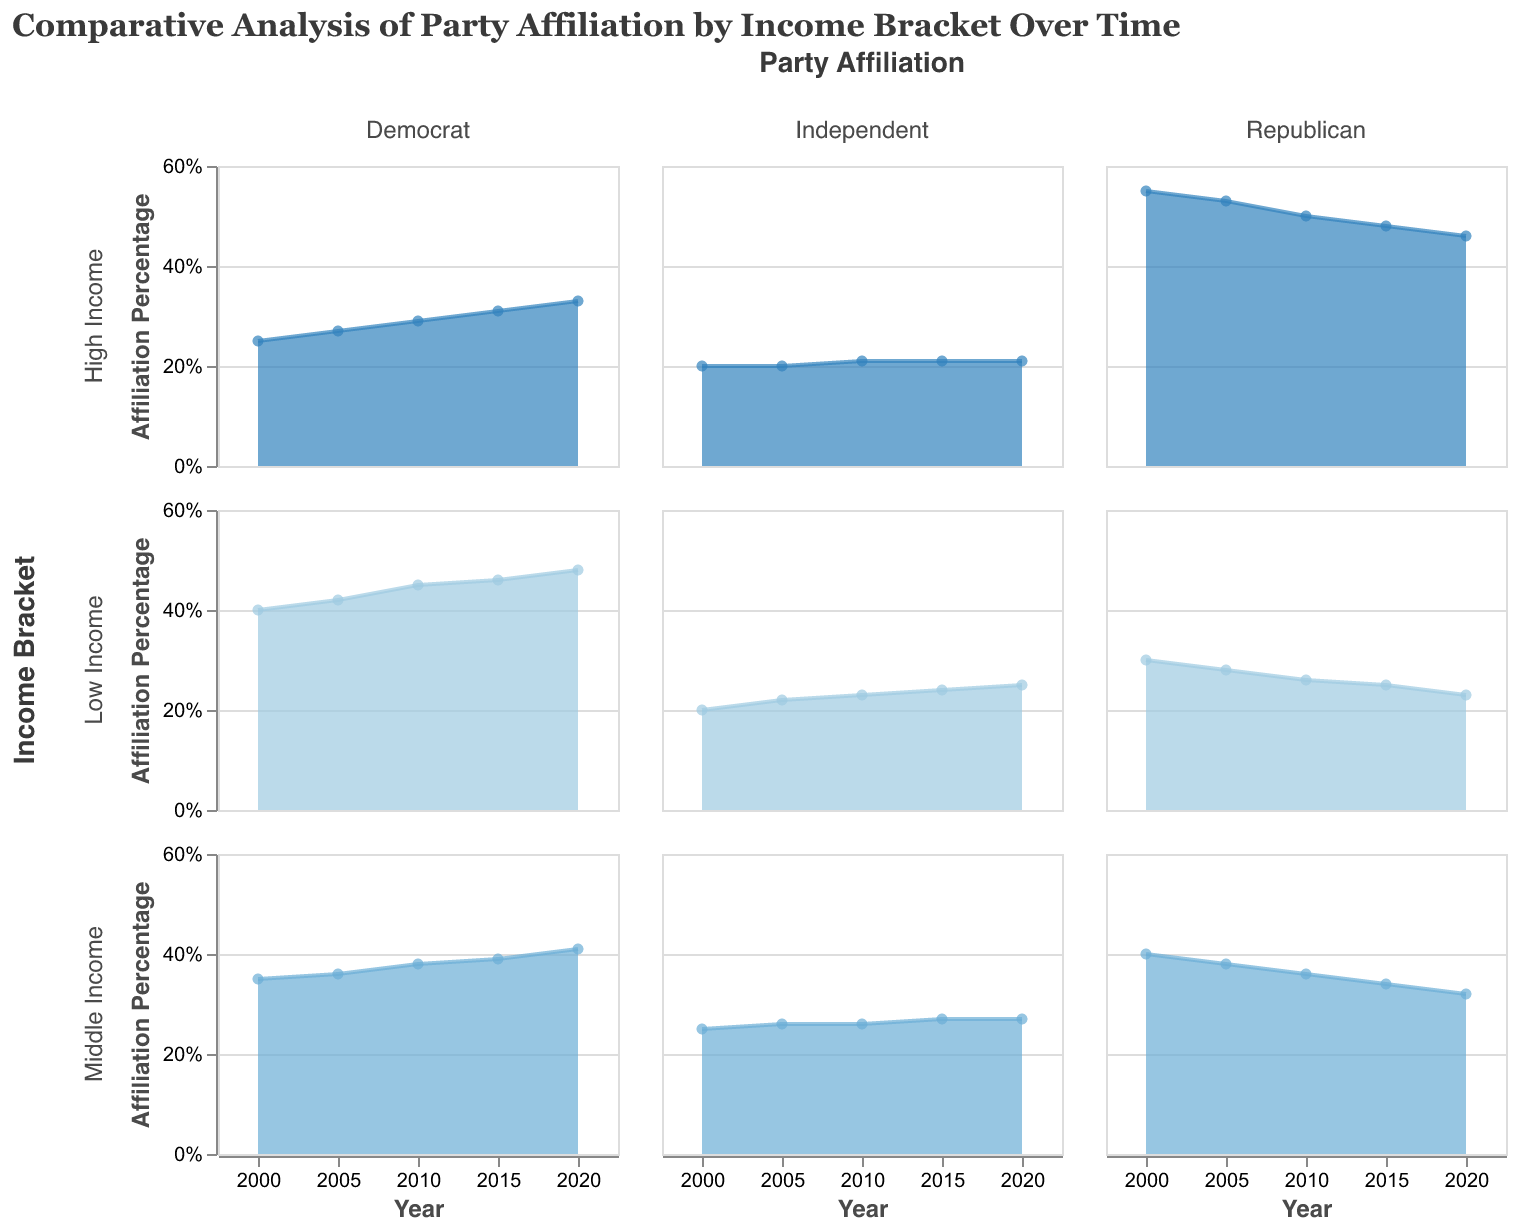What is the title of the figure? The title of the figure is located at the top and reads "Comparative Analysis of Party Affiliation by Income Bracket Over Time."
Answer: Comparative Analysis of Party Affiliation by Income Bracket Over Time Which income bracket has the highest percentage of Democrat affiliation in 2020? Looking under the Democrat column in 2020, the values for Low Income, Middle Income, and High Income are 0.48, 0.41, and 0.33, respectively. The highest percentage is for Low Income at 0.48.
Answer: Low Income What is the trend of Republican affiliation for High Income from 2000 to 2020? In the High Income bracket under the Republican column, the percentages from 2000 to 2020 show a declining trend: 0.55, 0.53, 0.5, 0.48, and 0.46, respectively.
Answer: Declining Compare the change in affiliation percentage for Middle Income Democrats and Republicans from 2000 to 2020. For Middle Income Democrats, the percentage goes from 0.35 in 2000 to 0.41 in 2020, an increase of 0.06. For Middle Income Republicans, the percentage goes from 0.4 in 2000 to 0.32 in 2020, a decrease of 0.08.
Answer: Democrats increased by 0.06, Republicans decreased by 0.08 Between 2000 and 2020, which party affiliation for Low Income had the most significant change? Looking under Low Income from 2000 to 2020 for all three parties: Democrat increased from 0.4 to 0.48 (0.08), Republican decreased from 0.3 to 0.23 (0.07), Independent increased from 0.2 to 0.25 (0.05). The most significant change is Democrats with an increase of 0.08.
Answer: Democrat What was the percentage of Independent affiliation for Middle Income in 2010? Under the Independent column for Middle Income in 2010, the percentage is given as 0.26.
Answer: 0.26 Which party affiliation category shows the least change over time for High Income? Looking at the High Income row, the changes from 2000 to 2020 are: Democrat (0.25 to 0.33, a change of 0.08), Republican (0.55 to 0.46, a change of 0.09), and Independent (0.2 to 0.21, a change of 0.01). The Independent category exhibits the least change.
Answer: Independent What is the overall trend for Independent affiliation across all income brackets from 2000 to 2020? For all income brackets (Low, Middle, High) under Independent, the overall trend from 2000 to 2020 is: Low Income (0.2 to 0.25), Middle Income (0.25 to 0.27), High Income (0.2 to 0.21). In general, Independent affiliation is either slightly increasing or stable.
Answer: Slightly increasing or stable Between 2000 and 2020, which income bracket shows the highest increase in Democrat affiliation? Looking at the Democrat row for all income brackets from 2000 to 2020: Low Income (0.4 to 0.48, change of 0.08), Middle Income (0.35 to 0.41, change of 0.06), High Income (0.25 to 0.33, change of 0.08). Both Low Income and High Income show the highest increase of 0.08.
Answer: Low Income and High Income 